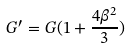Convert formula to latex. <formula><loc_0><loc_0><loc_500><loc_500>G ^ { \prime } = G ( 1 + \frac { 4 \beta ^ { 2 } } { 3 } )</formula> 